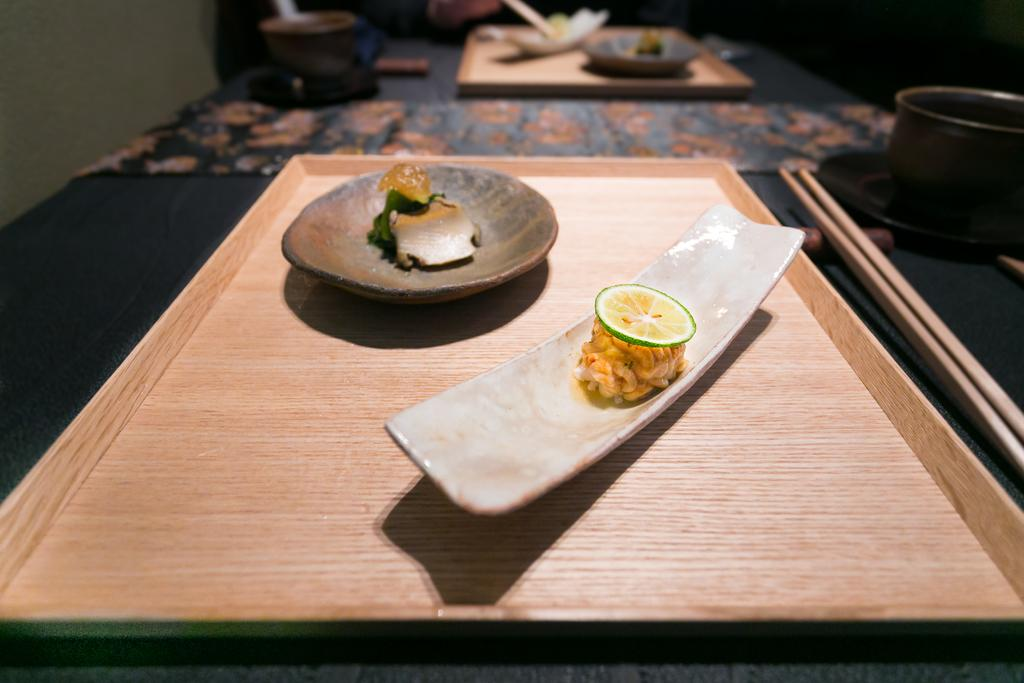What is on the plate that is visible in the image? There is food in a plate in the image. What type of fruit can be seen in the image? There is a lemon in the image. Are there any other plates with food in the image? Yes, there is food in another plate in the image. What is the surface that the plates are placed on? The plates are placed on a wooden plate. Where is the wooden plate located? The wooden plate is on a table. How many chopsticks are visible in the image? There are 2 chopsticks in the image. What other dishware is present in the image? There is a bowl and a saucer in the image. What invention is being demonstrated in the image? There is no invention being demonstrated in the image; it shows food, plates, and other dishware. Where is the drawer located in the image? There is no drawer present in the image. 